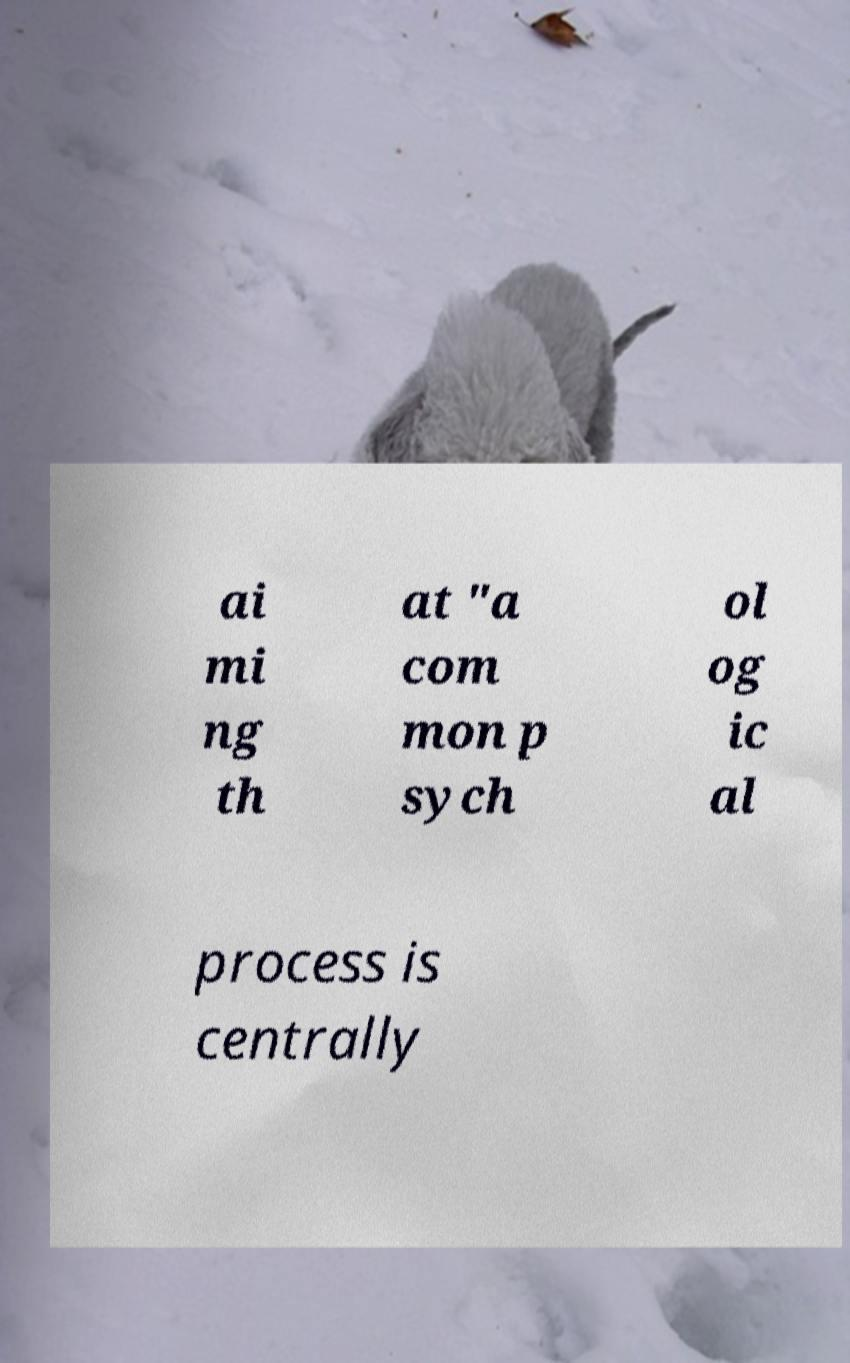Can you read and provide the text displayed in the image?This photo seems to have some interesting text. Can you extract and type it out for me? ai mi ng th at "a com mon p sych ol og ic al process is centrally 